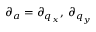<formula> <loc_0><loc_0><loc_500><loc_500>\partial _ { a } = \partial _ { q _ { x } } , \, \partial _ { q _ { y } }</formula> 